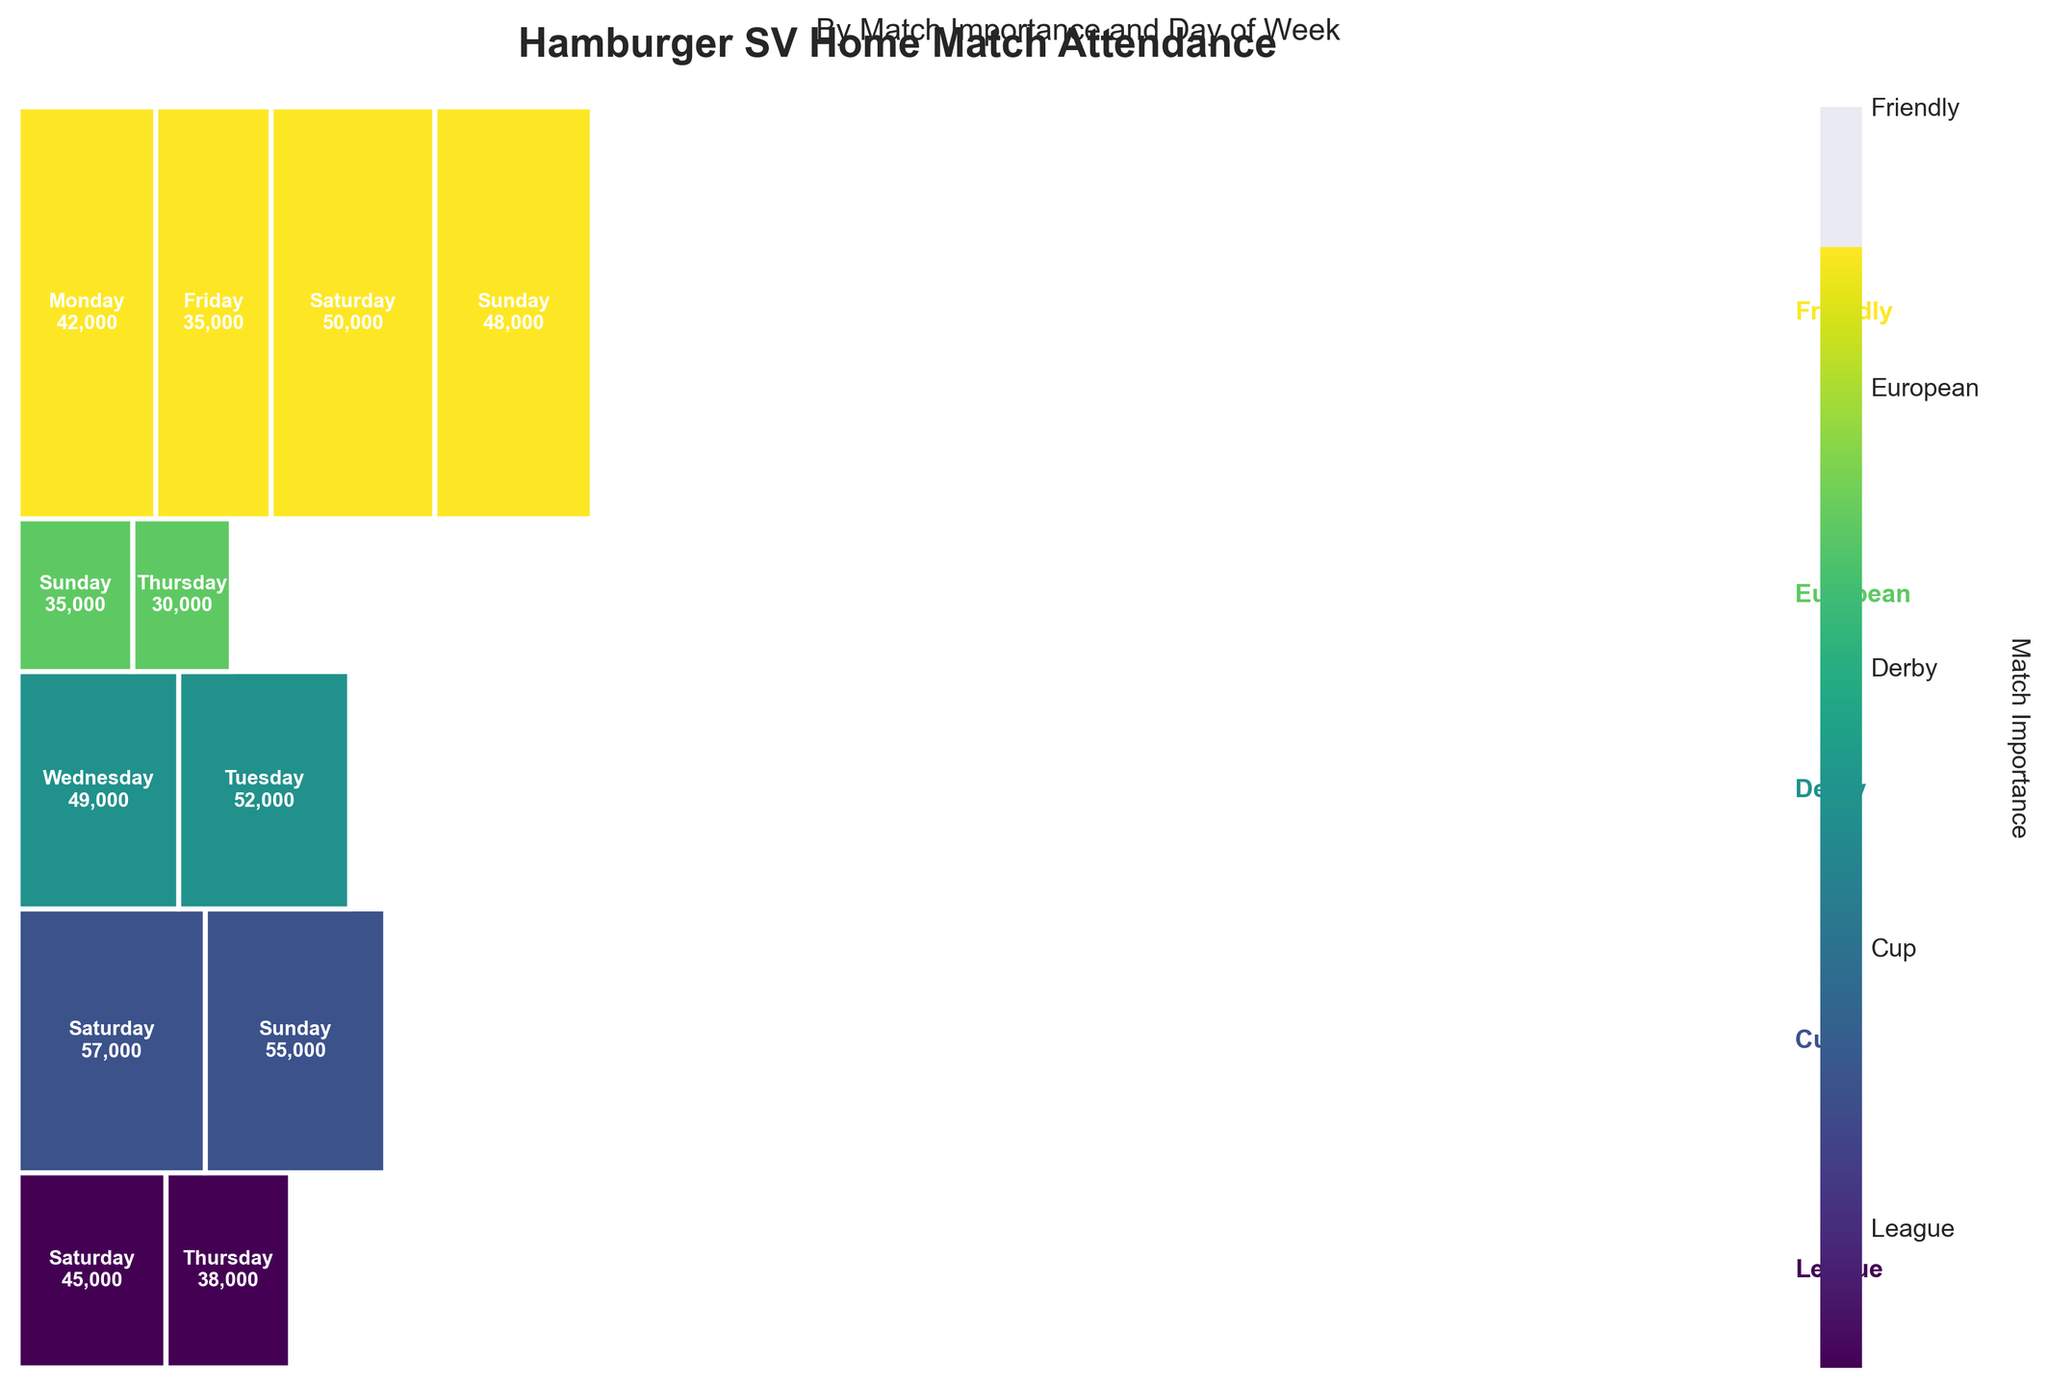What's the highest attendance recorded for a League match on any day? Look at the section of the mosaic plot representing League matches, and then identify the day with the highest attendance within that section. The highest recorded attendance for a League match is on Saturday with 50,000 attendees.
Answer: 50,000 How does the attendance on Fridays for League matches compare to the attendance on Mondays for the same type of matches? Compare the respective rectangles representing League matches on Fridays (42,000) and Mondays (35,000). The attendance on Fridays is higher than on Mondays.
Answer: Fridays have higher attendance Which type of match has the lowest attendance on Wednesdays? Examine the segments corresponding to Wednesday. The event with the lowest attendance on Wednesday is the Friendly match, with 30,000.
Answer: Friendly What's the difference in attendance between Derby and League matches on Saturdays? Check the Saturday sections for Derby (57,000) and League (50,000) matches. The difference is 57,000 - 50,000 = 7,000.
Answer: 7,000 What is the average attendance for Cup matches across all days? Identify the attendance values for Cup matches on Wednesday (38,000) and Saturday (45,000) and calculate the average: (38,000 + 45,000) / 2 = 41,500.
Answer: 41,500 How does the attendance for European matches on Thursdays compare to that on Tuesdays? Compare the attendance for European matches on Thursdays (49,000) and Tuesdays (52,000). The attendance on Tuesdays is greater.
Answer: Tuesdays have higher attendance Are there more attendees for League matches on Saturdays or Sundays? Compare the segments for League matches on Saturdays (50,000) and Sundays (48,000). There are more attendees on Saturdays.
Answer: Saturdays What's the total attendance for Cup matches? Sum the attendance for Cup matches on Wednesday (38,000) and Saturday (45,000): 38,000 + 45,000 = 83,000.
Answer: 83,000 Which type of match draws the largest crowd on Sundays? Check the Sunday segments for each match type: League (48,000), Derby (55,000), and Friendly (35,000). Derby matches draw the largest crowd on Sundays with 55,000 attendees.
Answer: Derby 